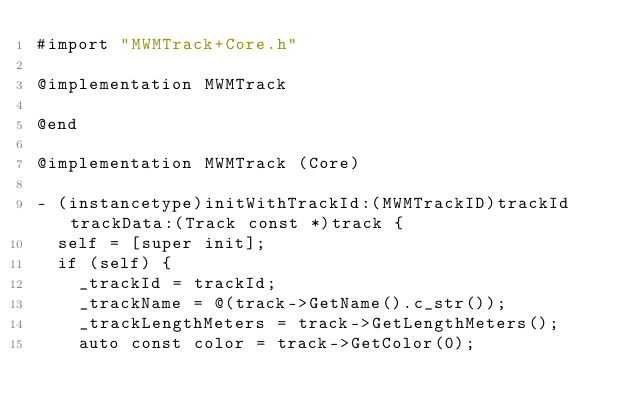<code> <loc_0><loc_0><loc_500><loc_500><_ObjectiveC_>#import "MWMTrack+Core.h"

@implementation MWMTrack

@end

@implementation MWMTrack (Core)

- (instancetype)initWithTrackId:(MWMTrackID)trackId trackData:(Track const *)track {
  self = [super init];
  if (self) {
    _trackId = trackId;
    _trackName = @(track->GetName().c_str());
    _trackLengthMeters = track->GetLengthMeters();
    auto const color = track->GetColor(0);</code> 